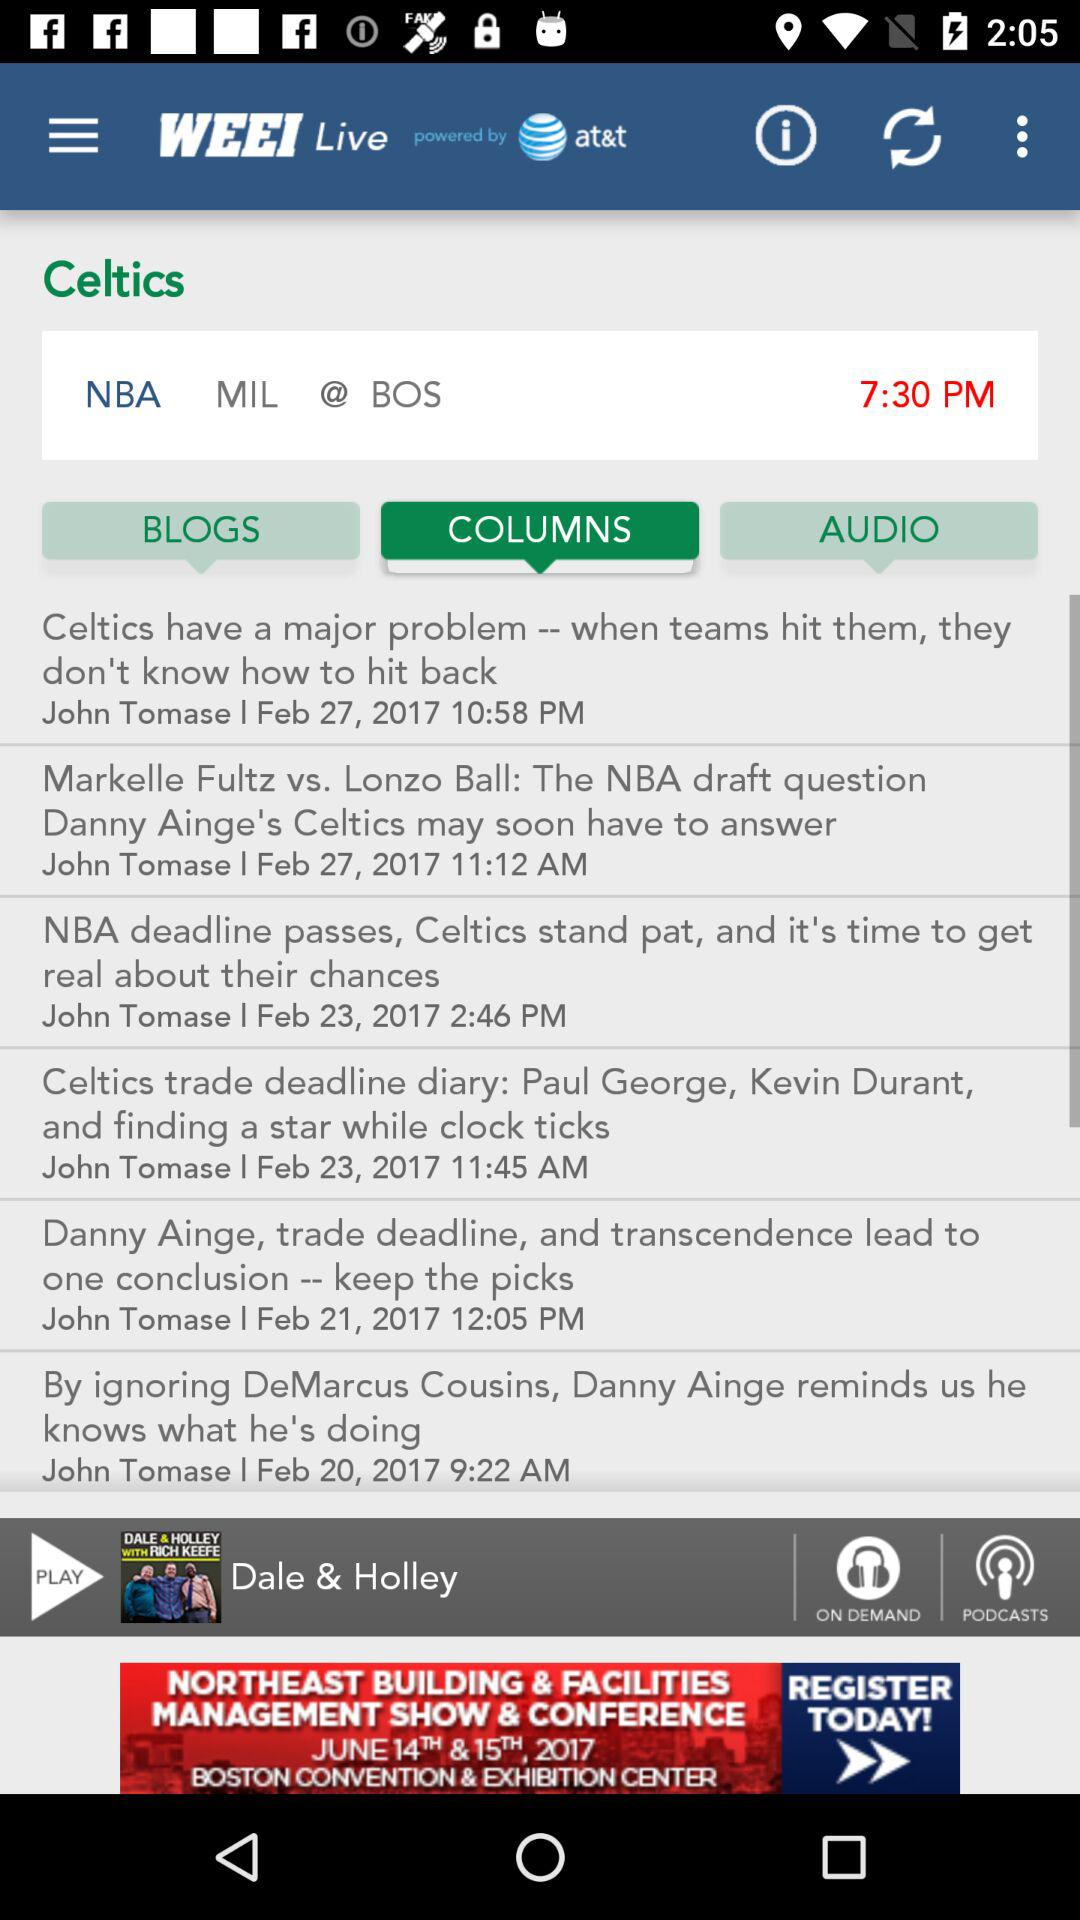On what date was the article "Celtics have a major problem -- when teams hit them, they don't know how to hit back" posted? The article "Celtics have a major problem -- when teams hit them, they don't know how to hit back" was posted on February 27, 2017. 